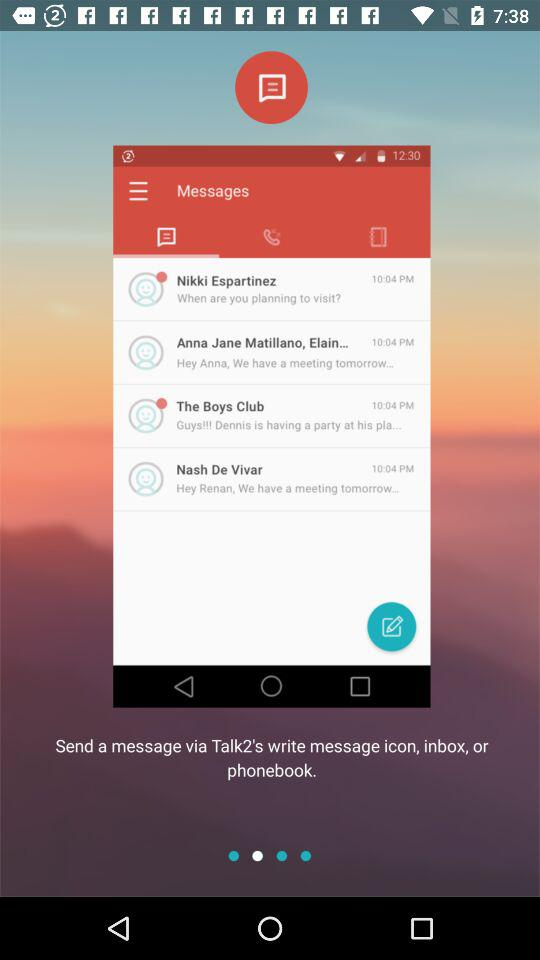What is the message time of Nash De Vivar? The message time is 10:04 PM. 